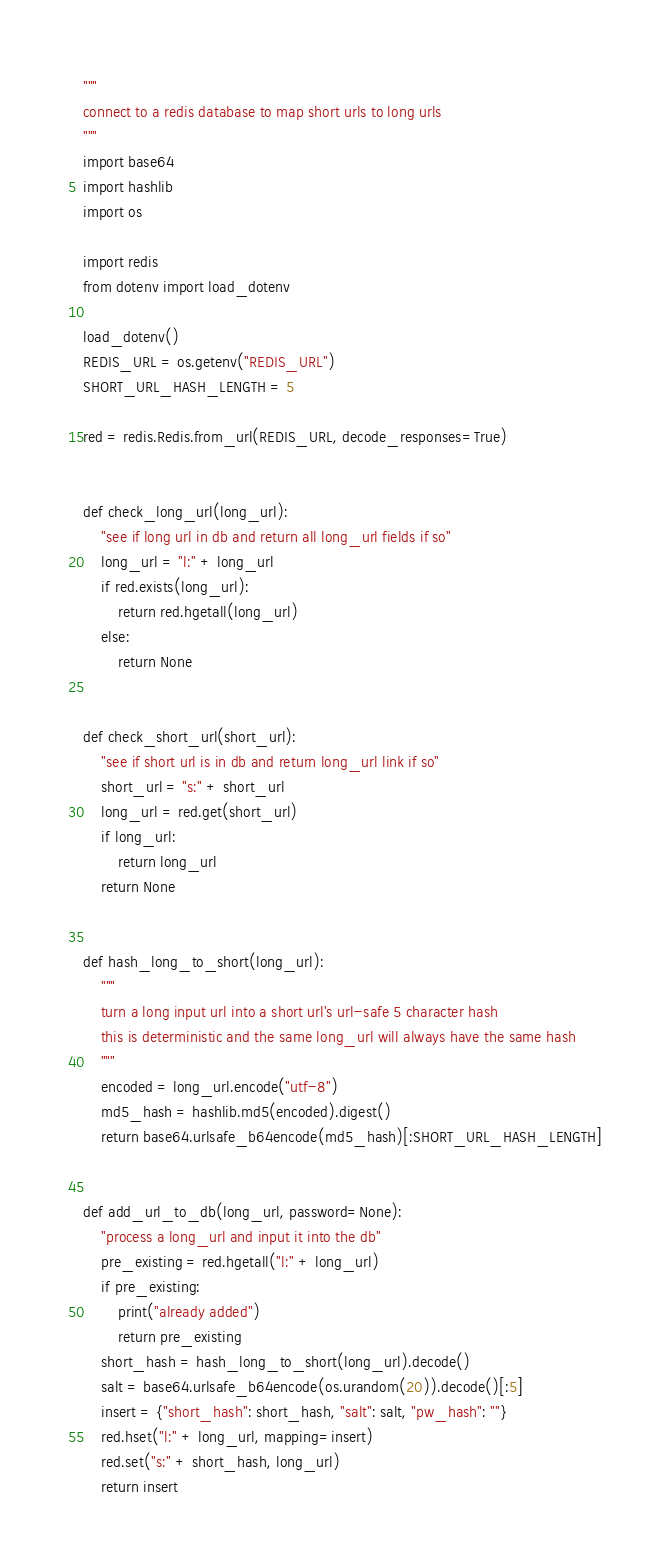<code> <loc_0><loc_0><loc_500><loc_500><_Python_>"""
connect to a redis database to map short urls to long urls
"""
import base64
import hashlib
import os

import redis
from dotenv import load_dotenv

load_dotenv()
REDIS_URL = os.getenv("REDIS_URL")
SHORT_URL_HASH_LENGTH = 5

red = redis.Redis.from_url(REDIS_URL, decode_responses=True)


def check_long_url(long_url):
    "see if long url in db and return all long_url fields if so"
    long_url = "l:" + long_url
    if red.exists(long_url):
        return red.hgetall(long_url)
    else:
        return None


def check_short_url(short_url):
    "see if short url is in db and return long_url link if so"
    short_url = "s:" + short_url
    long_url = red.get(short_url)
    if long_url:
        return long_url
    return None


def hash_long_to_short(long_url):
    """
    turn a long input url into a short url's url-safe 5 character hash
    this is deterministic and the same long_url will always have the same hash
    """
    encoded = long_url.encode("utf-8")
    md5_hash = hashlib.md5(encoded).digest()
    return base64.urlsafe_b64encode(md5_hash)[:SHORT_URL_HASH_LENGTH]


def add_url_to_db(long_url, password=None):
    "process a long_url and input it into the db"
    pre_existing = red.hgetall("l:" + long_url)
    if pre_existing:
        print("already added")
        return pre_existing
    short_hash = hash_long_to_short(long_url).decode()
    salt = base64.urlsafe_b64encode(os.urandom(20)).decode()[:5]
    insert = {"short_hash": short_hash, "salt": salt, "pw_hash": ""}
    red.hset("l:" + long_url, mapping=insert)
    red.set("s:" + short_hash, long_url)
    return insert
</code> 